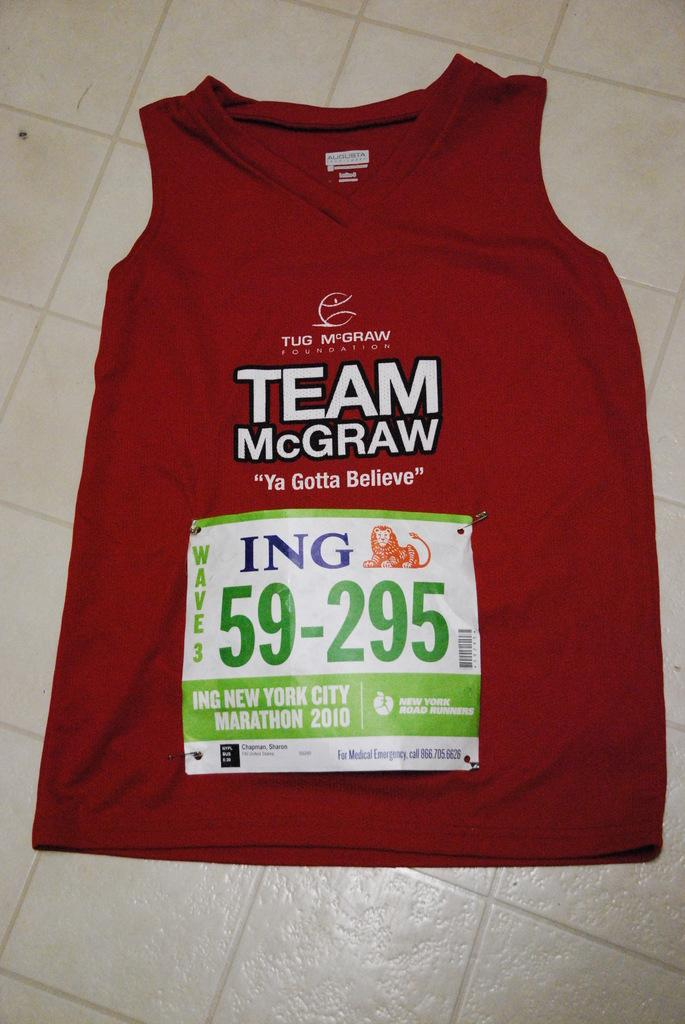<image>
Present a compact description of the photo's key features. A Team McGraw shirt is laid out on a kitchen floor. 